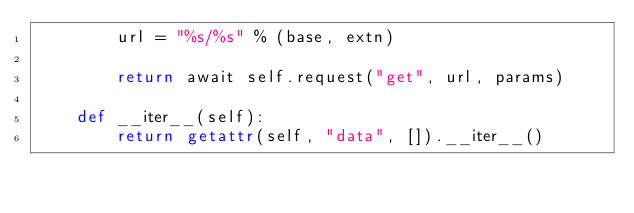Convert code to text. <code><loc_0><loc_0><loc_500><loc_500><_Python_>        url = "%s/%s" % (base, extn)

        return await self.request("get", url, params)

    def __iter__(self):
        return getattr(self, "data", []).__iter__()
</code> 